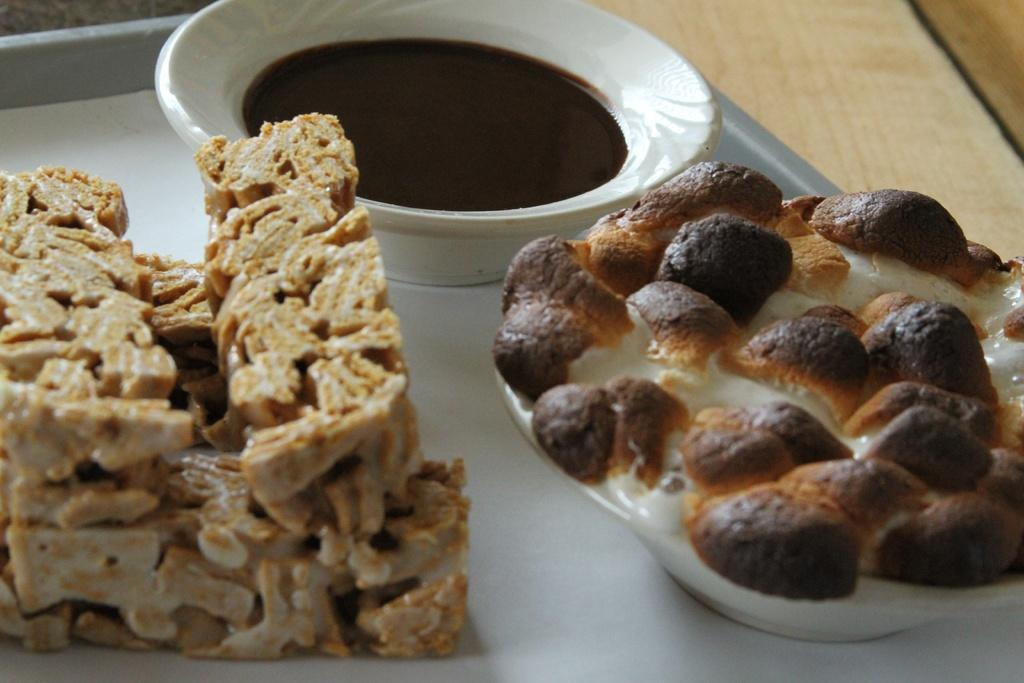What type of items can be seen in the image? There are food items and bowls in the image. How are the food items and bowls arranged? The food items and bowls are on a tray or plate. What is the tray or plate placed on? The tray or plate is placed on an object. Can you see any deer in the image? No, there are no deer present in the image. What type of office furniture can be seen in the image? There is no office furniture present in the image. 